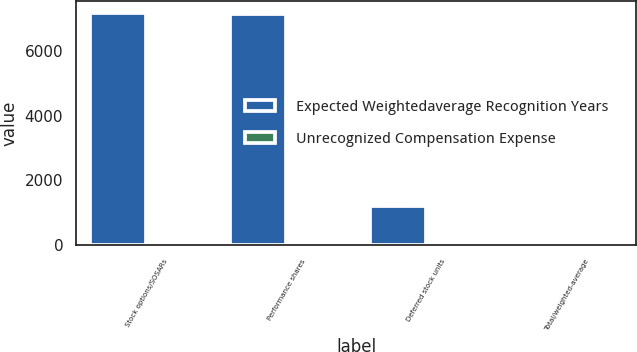Convert chart. <chart><loc_0><loc_0><loc_500><loc_500><stacked_bar_chart><ecel><fcel>Stock options/SOSARs<fcel>Performance shares<fcel>Deferred stock units<fcel>Total/weighted-average<nl><fcel>Expected Weightedaverage Recognition Years<fcel>7165<fcel>7127<fcel>1220<fcel>1.7<nl><fcel>Unrecognized Compensation Expense<fcel>1.2<fcel>1.7<fcel>1<fcel>1.4<nl></chart> 